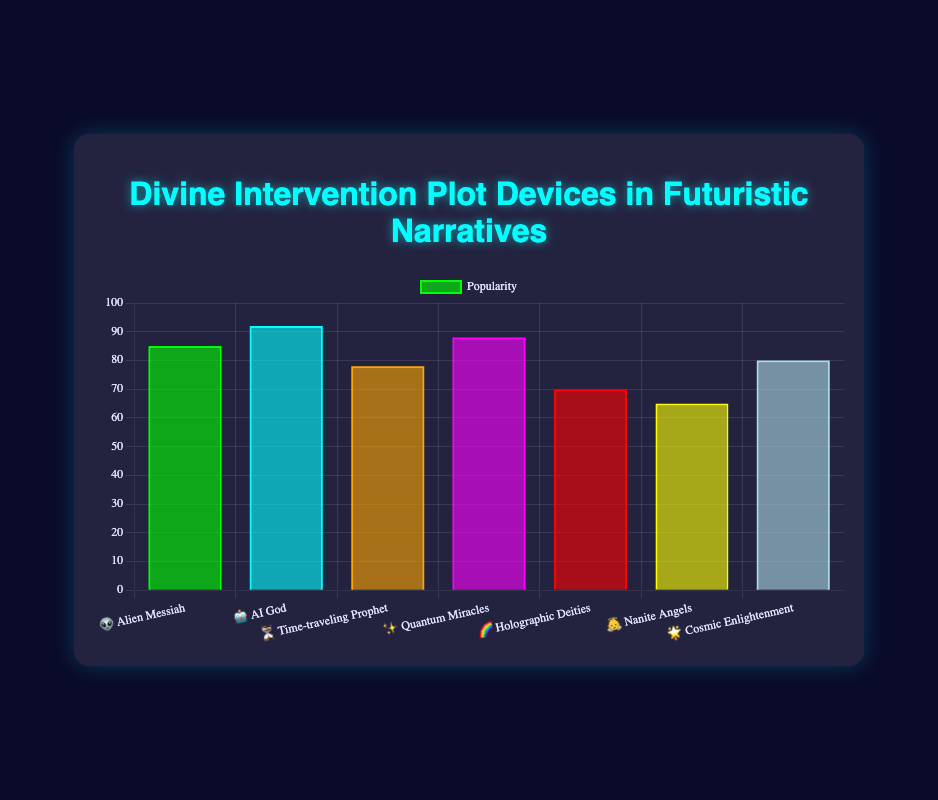What is the title of the chart? To find the chart title, look at the top of the figure where the title is usually placed.
Answer: Divine Intervention Plot Devices in Futuristic Narratives Which plot device has the highest popularity? Look at the bar that reaches the highest value on the y-axis.
Answer: AI God 🤖 What is the popularity range of the plot devices? Identify the minimum and maximum popularity values depicted in the bars. The minimum popularity is 65, and the maximum is 92. To find the range, subtract the minimum from the maximum: 92 - 65 = 27
Answer: 27 Which plot devices have a popularity greater than 80? Identify all bars exceeding the 80 mark on the y-axis. These are Alien Messiah, AI God, Quantum Miracles, and Cosmic Enlightenment.
Answer: Alien Messiah 👽, AI God 🤖, Quantum Miracles ✨, and Cosmic Enlightenment 🌟 What is the total popularity value for Time-traveling Prophet and Quantum Miracles? Sum the numbers representing the popularity of Time-traveling Prophet (78) and Quantum Miracles (88): 78 + 88 = 166
Answer: 166 Which plot device has the lowest popularity? Look at the bar that reaches the lowest value on the y-axis.
Answer: Nanite Angels 👼 By how much is the popularity of AI God greater than Holographic Deities? Subtract the popularity of Holographic Deities (70) from AI God (92): 92 - 70 = 22
Answer: 22 Rank the plot devices from most to least popular. Arrange the popularity values in descending order: AI God (92), Quantum Miracles (88), Alien Messiah (85), Cosmic Enlightenment (80), Time-traveling Prophet (78), Holographic Deities (70), Nanite Angels (65).
Answer: AI God 🤖, Quantum Miracles ✨, Alien Messiah 👽, Cosmic Enlightenment 🌟, Time-traveling Prophet ⏳, Holographic Deities 🌈, Nanite Angels 👼 How many plot devices have a popularity below 75? Count the bars that are below the 75 mark on the y-axis. These are Holographic Deities and Nanite Angels.
Answer: 2 